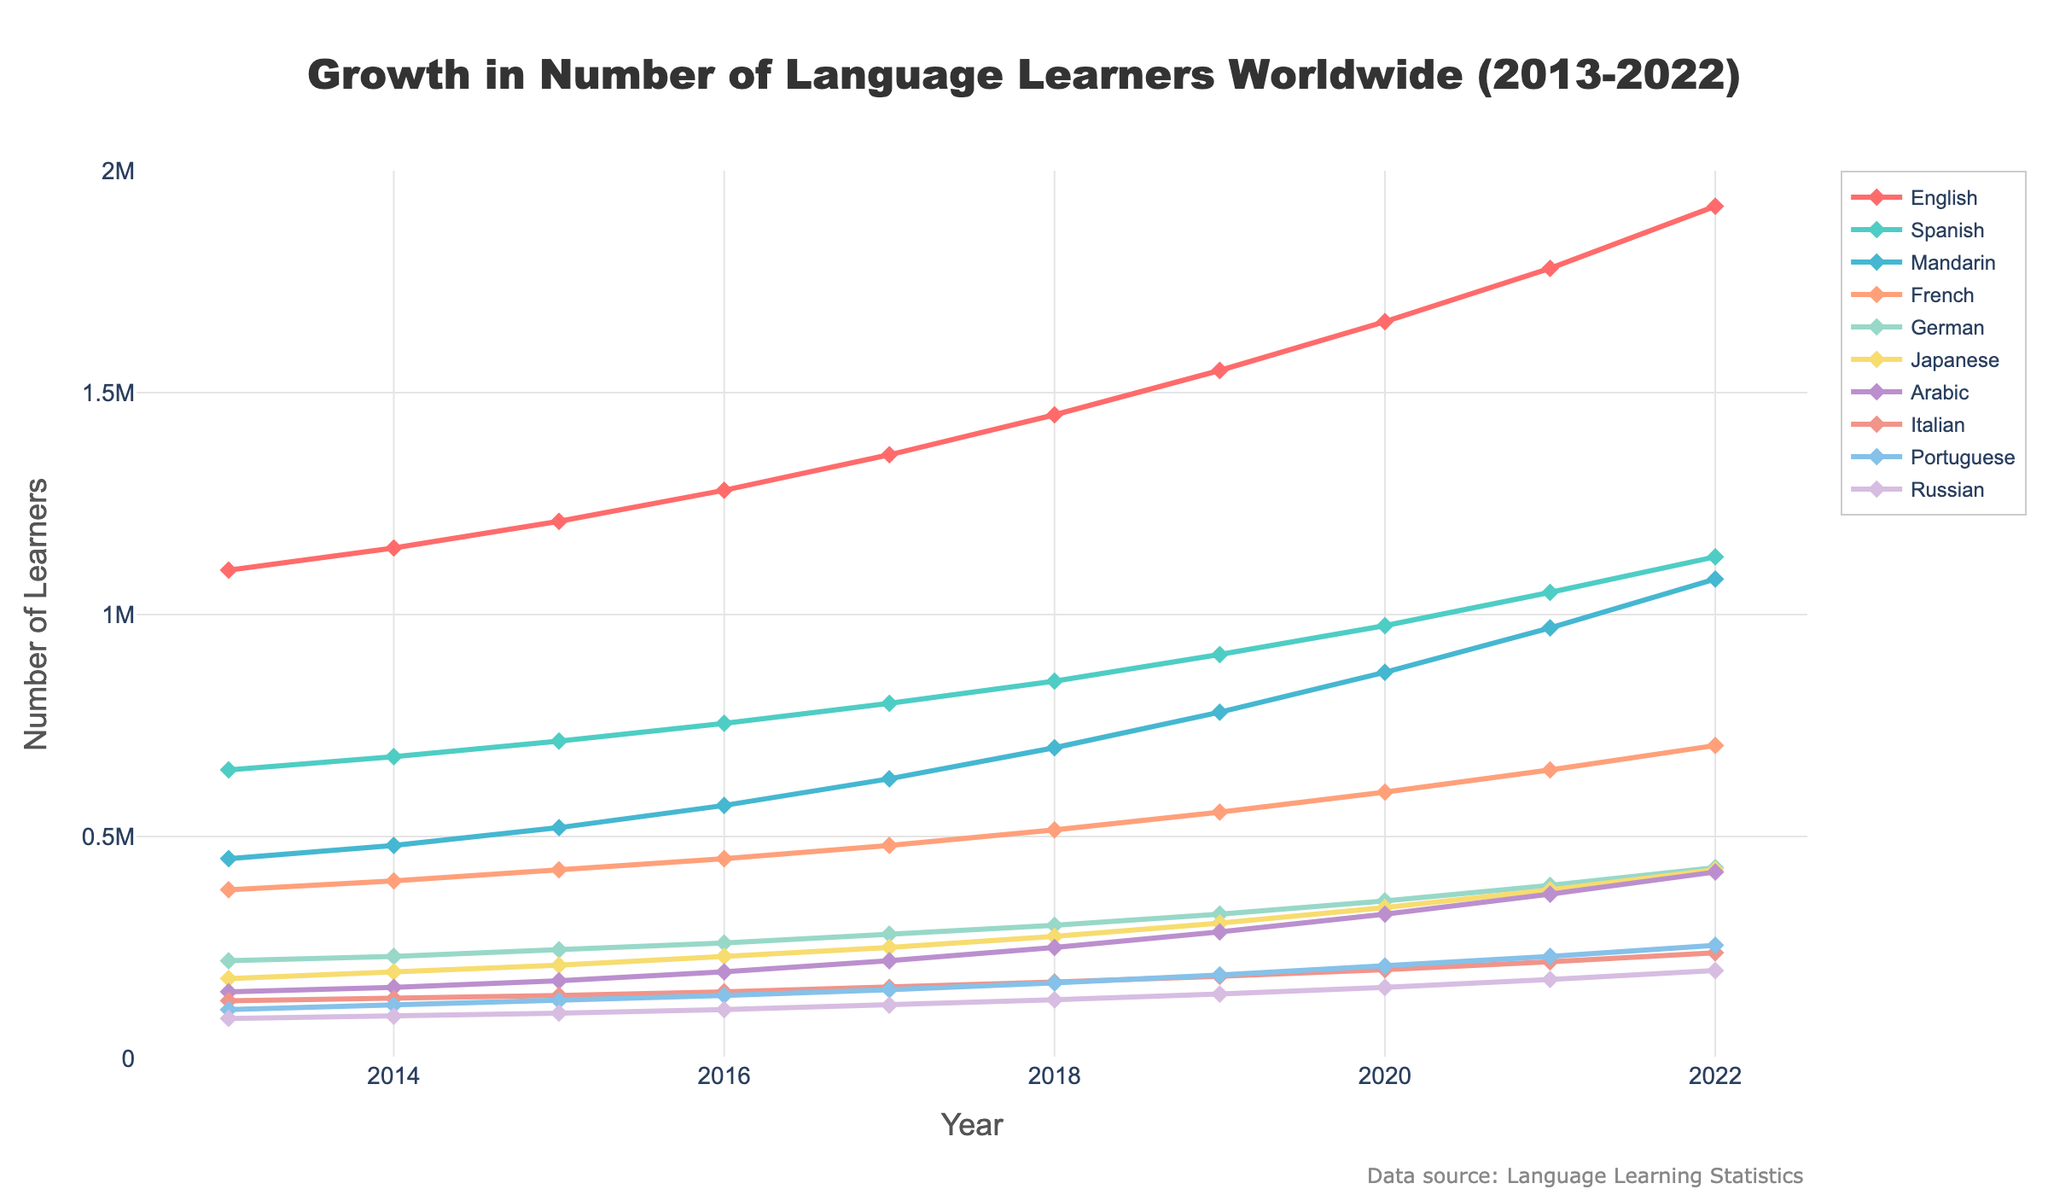Which language had the highest number of learners in 2022? By looking at the height of the lines in 2022, English had the highest number of learners.
Answer: English How many learners were there for French in 2016 and 2017 combined? The number of French learners in 2016 was 450,000 and in 2017 was 480,000. Therefore, combined it is 450,000 + 480,000 = 930,000.
Answer: 930,000 Which language showed the most growth from 2013 to 2022? Visual inspection of the slopes shows that English had the steepest increase. The growth for English from 2013 to 2022 is 1,920,000 - 1,100,000 = 820,000.
Answer: English Compare the growth rates of Spanish and Mandarin from 2019 to 2020. Which one grew faster? Spanish grew from 910,000 to 975,000 (an increase of 65,000) while Mandarin grew from 780,000 to 870,000 (an increase of 90,000). Therefore, Mandarin grew faster.
Answer: Mandarin What is the average number of learners for Japanese from 2020 to 2022? The number of learners for Japanese from 2020 to 2022 are 340,000, 380,000, and 425,000 respectively. The average is (340,000 + 380,000 + 425,000) / 3 = 1,145,000 / 3 = 381,666.67.
Answer: 381,667 Which language had the least number of learners in 2015? By analyzing the height of the lines in 2015, Russian had the least number of learners with 102,000.
Answer: Russian How many more learners did Italian have in 2022 compared to Portuguese in 2013? Italian had 238,000 learners in 2022 and Portuguese had 110,000 learners in 2013. So, 238,000 - 110,000 = 128,000 more learners.
Answer: 128,000 List the languages that surpassed 1,000,000 learners by 2021. By 2021, English, Spanish, and Mandarin had surpassed 1,000,000 learners as observed from their respective heights above the 1,000,000 mark.
Answer: English, Spanish, Mandarin What was the difference in the number of learners between German and Arabic in 2019? In 2019, German had 325,000 learners and Arabic had 285,000 learners. The difference is 325,000 - 285,000 = 40,000.
Answer: 40,000 Which year did Japanese learners exceed 300,000? Examining the line for Japanese, it exceeded 300,000 in 2018.
Answer: 2018 